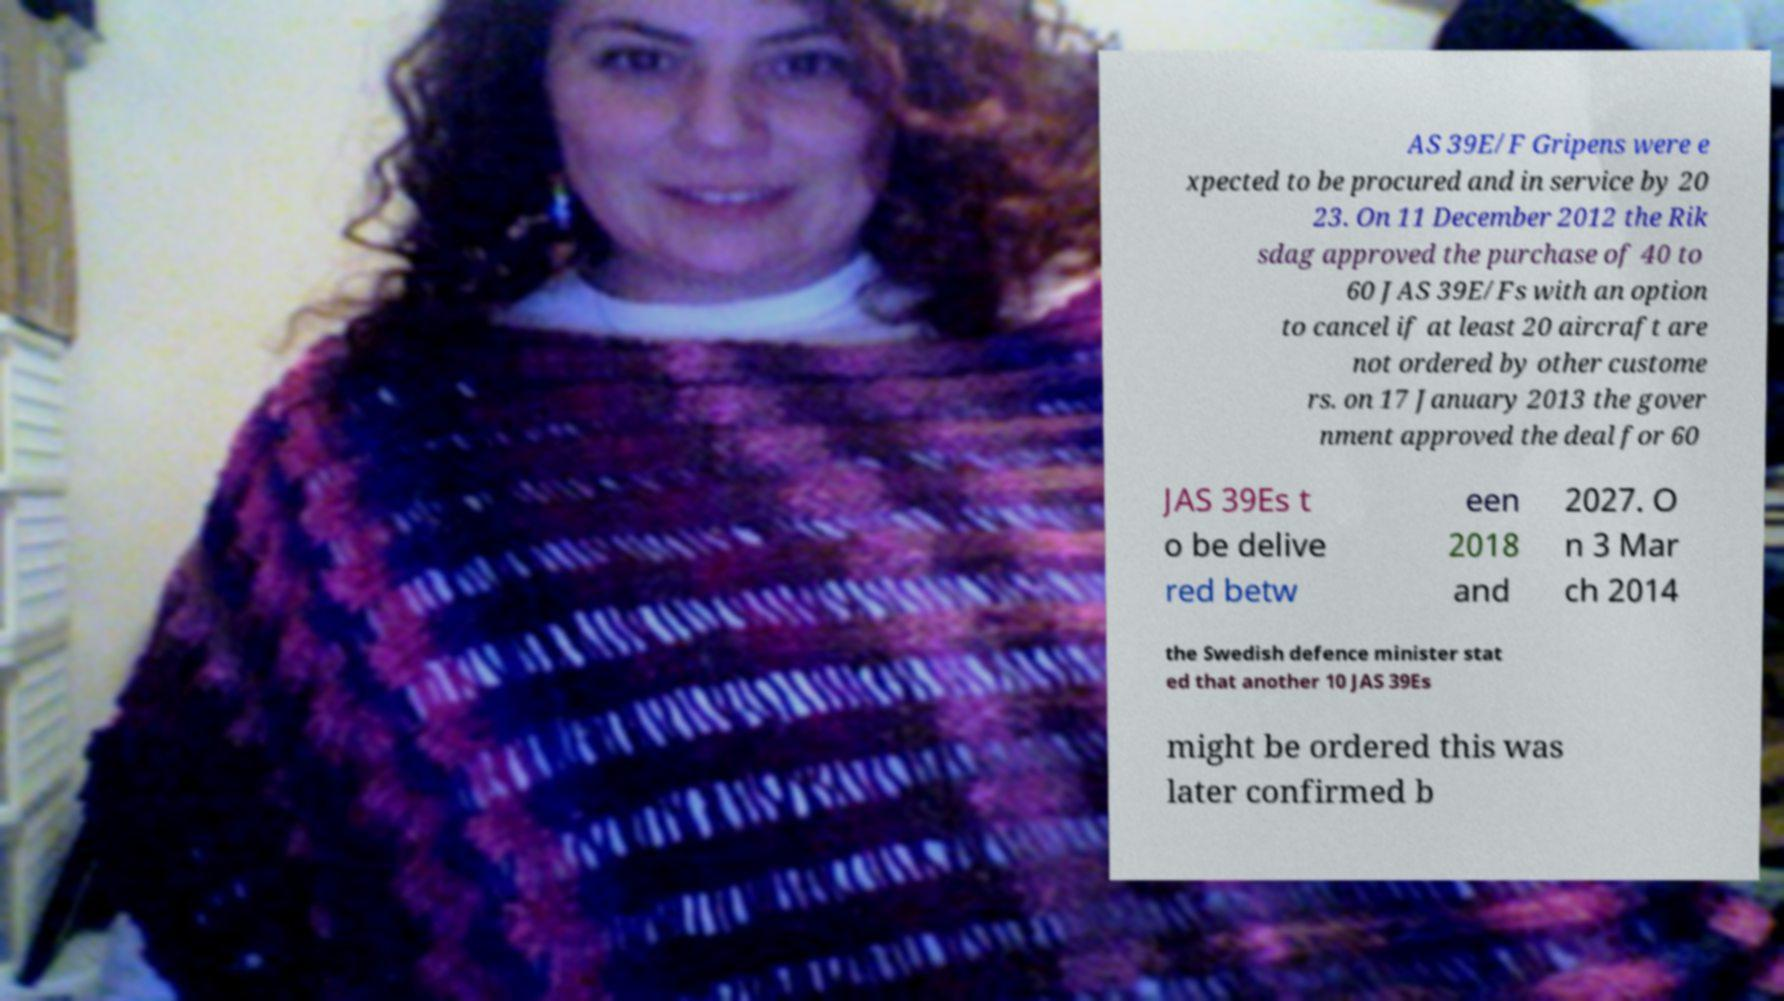For documentation purposes, I need the text within this image transcribed. Could you provide that? AS 39E/F Gripens were e xpected to be procured and in service by 20 23. On 11 December 2012 the Rik sdag approved the purchase of 40 to 60 JAS 39E/Fs with an option to cancel if at least 20 aircraft are not ordered by other custome rs. on 17 January 2013 the gover nment approved the deal for 60 JAS 39Es t o be delive red betw een 2018 and 2027. O n 3 Mar ch 2014 the Swedish defence minister stat ed that another 10 JAS 39Es might be ordered this was later confirmed b 